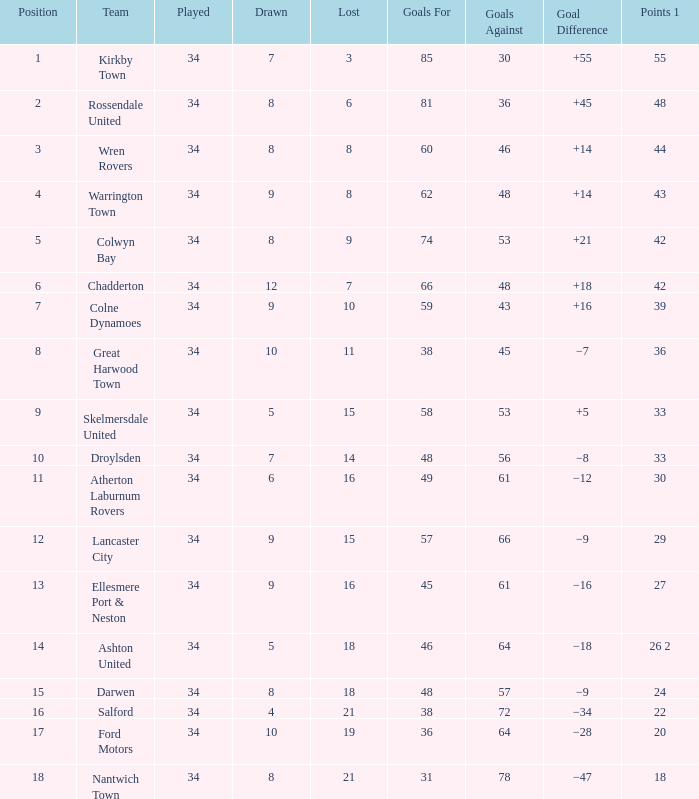What is the smallest number of goals against when there are 1 of 18 points, and more than 8 are drawn? None. 